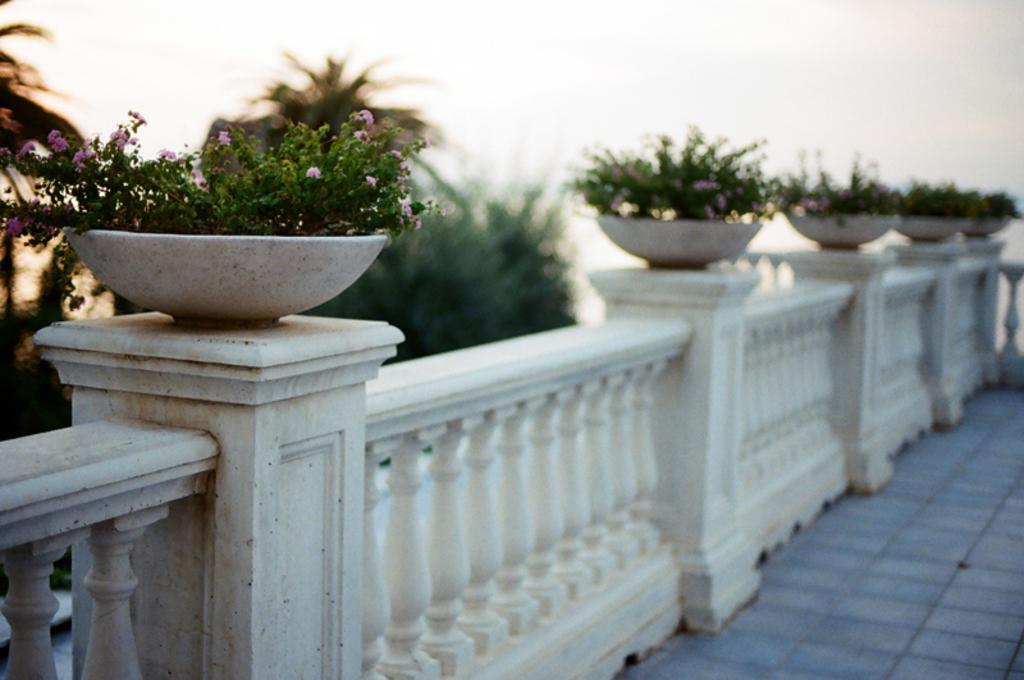What type of structure can be seen in the image? There is railing in the image, which suggests a balcony or staircase. What decorative items are present in the image? There are flower pots in the image, which contain plants and flowers. What type of vegetation is visible in the image? There are plants and trees in the image, as well as flowers. What is visible in the background of the image? The sky is visible in the image. What type of fan is visible in the image? There is no fan present in the image. Can you see a kitten playing with the plants in the image? There is no kitten present in the image. 